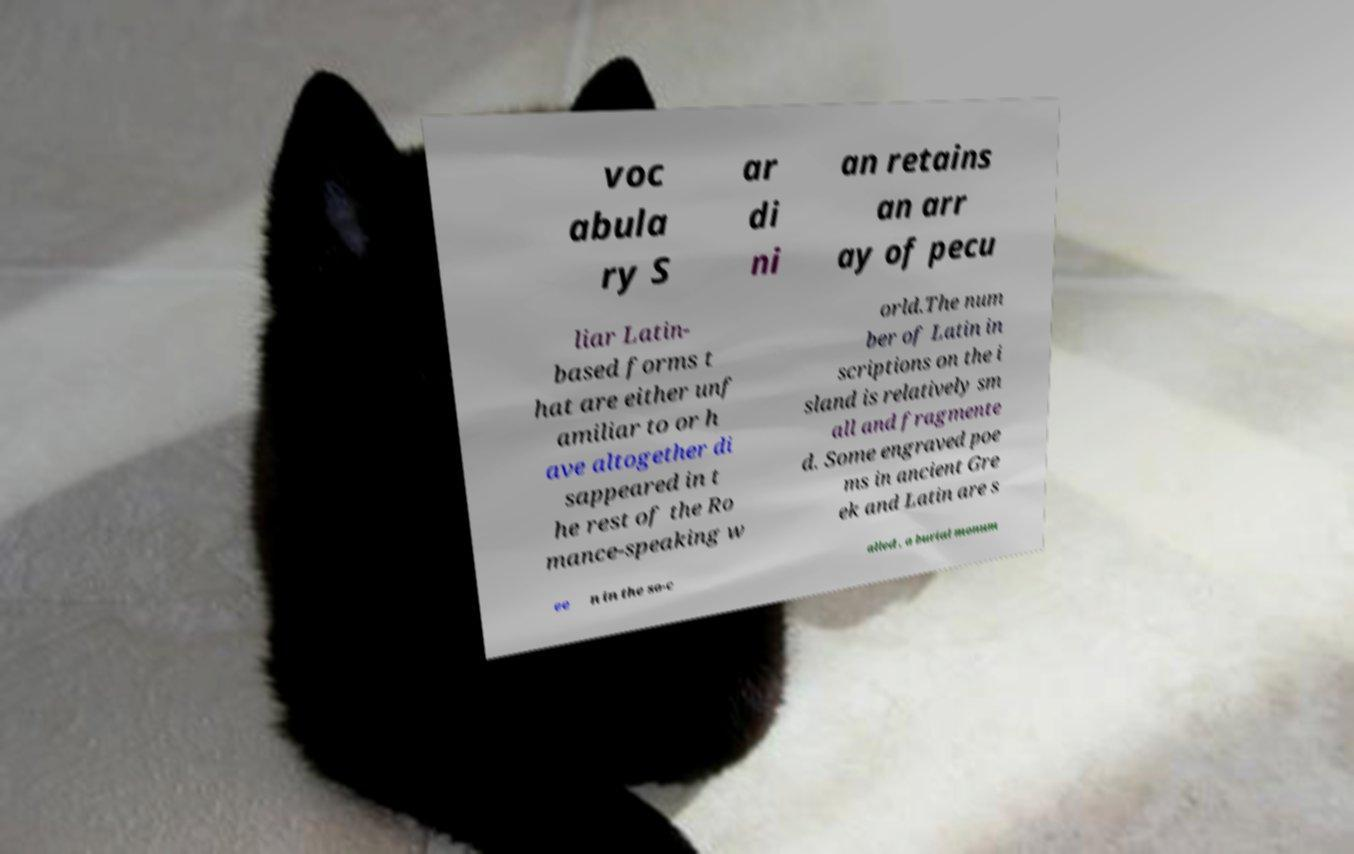Could you extract and type out the text from this image? voc abula ry S ar di ni an retains an arr ay of pecu liar Latin- based forms t hat are either unf amiliar to or h ave altogether di sappeared in t he rest of the Ro mance-speaking w orld.The num ber of Latin in scriptions on the i sland is relatively sm all and fragmente d. Some engraved poe ms in ancient Gre ek and Latin are s ee n in the so-c alled , a burial monum 